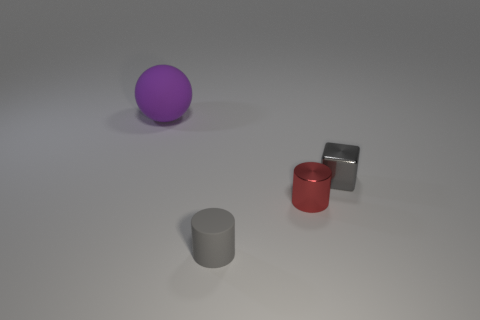Add 4 gray matte objects. How many objects exist? 8 Subtract all blocks. How many objects are left? 3 Subtract all small gray rubber objects. Subtract all small red cylinders. How many objects are left? 2 Add 2 small rubber things. How many small rubber things are left? 3 Add 4 red rubber cubes. How many red rubber cubes exist? 4 Subtract 1 red cylinders. How many objects are left? 3 